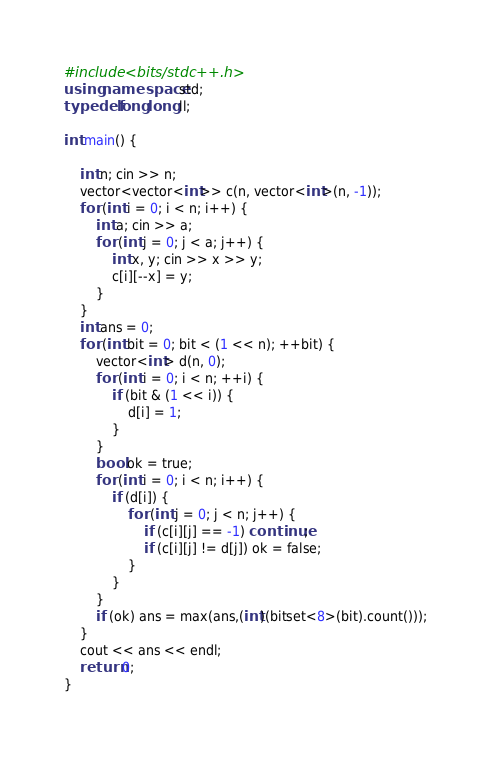<code> <loc_0><loc_0><loc_500><loc_500><_C++_>#include <bits/stdc++.h>
using namespace std;
typedef long long ll;

int main() {

	int n; cin >> n;
	vector<vector<int>> c(n, vector<int>(n, -1));
	for (int i = 0; i < n; i++) {
		int a; cin >> a;
		for (int j = 0; j < a; j++) {
			int x, y; cin >> x >> y;
			c[i][--x] = y;						
		}
	}
	int ans = 0;
	for (int bit = 0; bit < (1 << n); ++bit) {
		vector<int> d(n, 0);
		for (int i = 0; i < n; ++i) {
			if (bit & (1 << i)) {
				d[i] = 1;
			}
		}
		bool ok = true;
		for (int i = 0; i < n; i++) {
			if (d[i]) {
				for (int j = 0; j < n; j++) {
					if (c[i][j] == -1) continue;
					if (c[i][j] != d[j]) ok = false;
				}
			}
		}
		if (ok) ans = max(ans,(int)(bitset<8>(bit).count()));
	}
	cout << ans << endl;
	return 0;
}</code> 